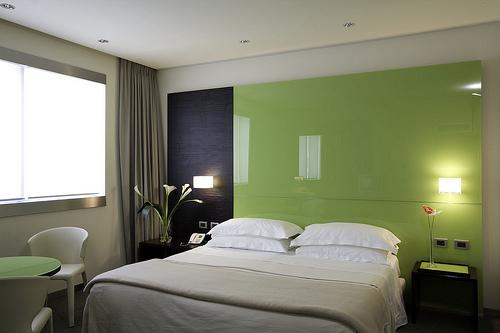Question: what color are the pillows?
Choices:
A. Black.
B. White.
C. Grey.
D. Blue.
Answer with the letter. Answer: B Question: how many people are there?
Choices:
A. None.
B. Two.
C. One.
D. Three.
Answer with the letter. Answer: A Question: where was the photo taken?
Choices:
A. Outside.
B. At the beach.
C. At the store.
D. A room.
Answer with the letter. Answer: D Question: what is shining through the window?
Choices:
A. Light.
B. Nothing.
C. Stars.
D. Sun.
Answer with the letter. Answer: A 